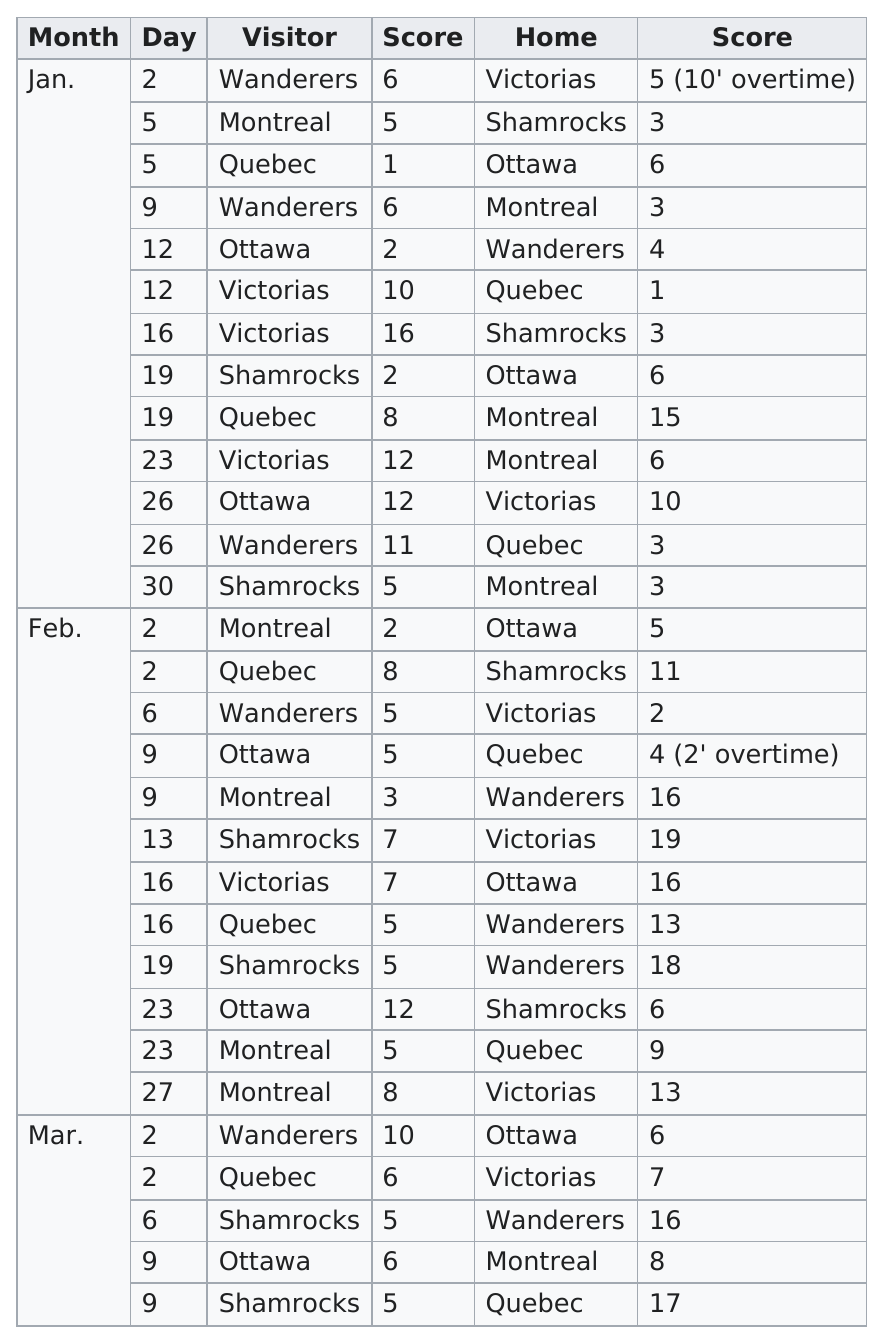Give some essential details in this illustration. The score of the first game on this chart was 6-5. On January 9th, the top scorer for the Wanderers was announced. The highest number of points scored by a team in a single game is 19 points. The score of the last game listed on this chart is 5-17. The number of times the score was more than seven for the visitors was ten. 